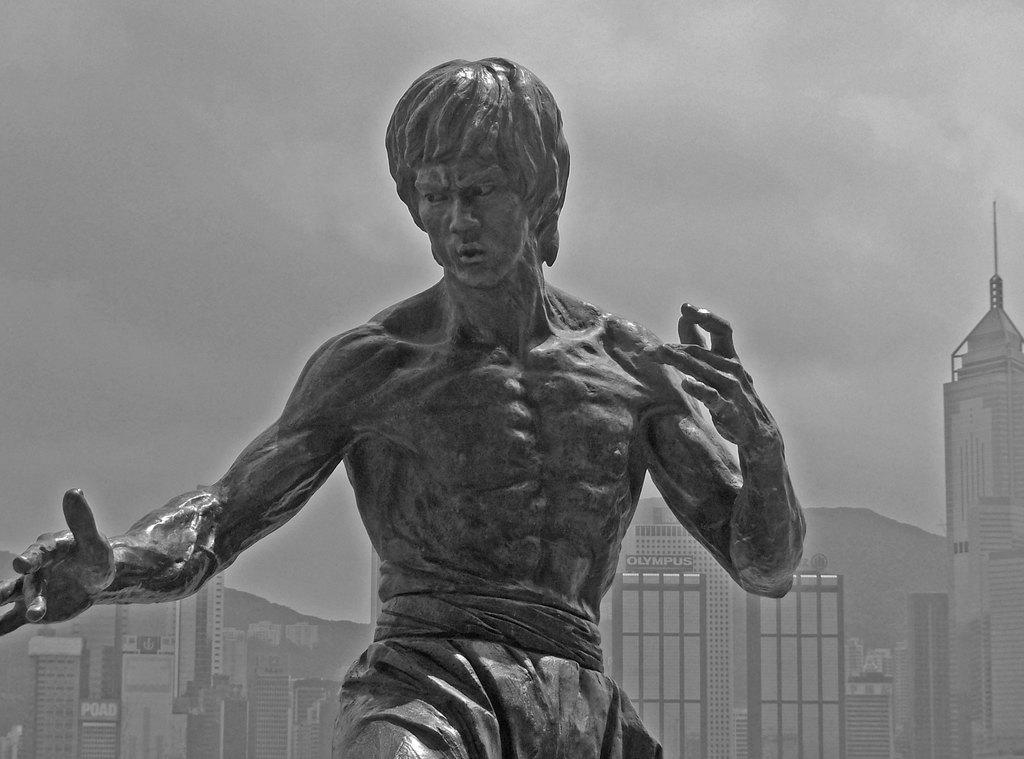Please provide a concise description of this image. In the center of the image we can see a statue. In the background there are buildings and sky. 